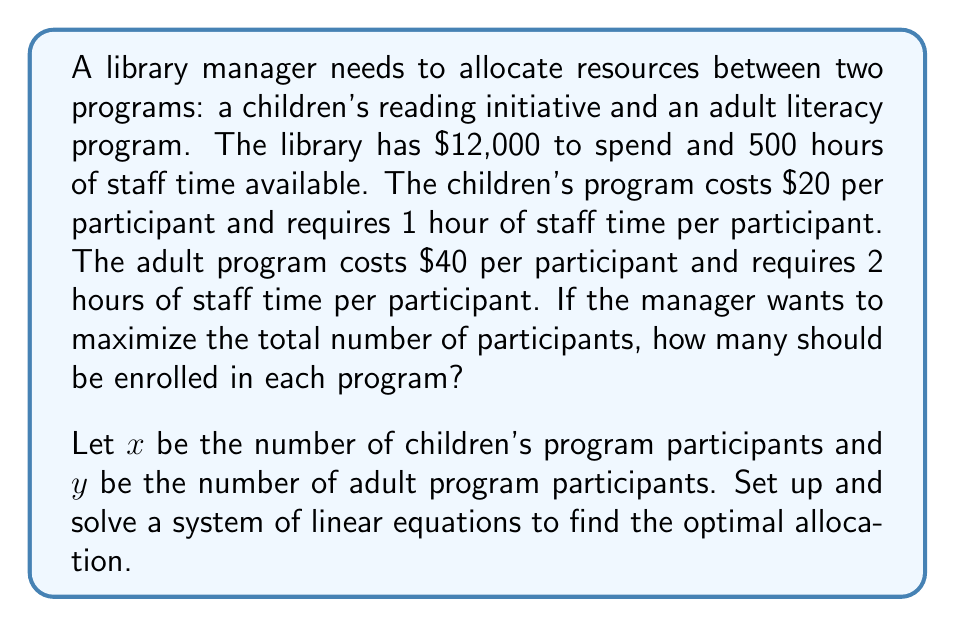Could you help me with this problem? 1. Set up the system of linear equations:

   Budget constraint: $20x + 40y = 12000$
   Time constraint: $x + 2y = 500$
   Objective: Maximize $x + y$

2. Simplify the budget constraint:
   $$20x + 40y = 12000$$
   $$x + 2y = 600$$

3. Now we have a system of two equations:
   $$x + 2y = 600$$
   $$x + 2y = 500$$

4. Solve for $x$ using substitution:
   From the second equation: $x = 500 - 2y$
   Substitute into the first equation:
   $$(500 - 2y) + 2y = 600$$
   $$500 = 600$$
   $$y = 50$$

5. Substitute $y = 50$ back into $x = 500 - 2y$:
   $$x = 500 - 2(50) = 400$$

6. Check the solution:
   Budget: $20(400) + 40(50) = 8000 + 2000 = 10000 \leq 12000$
   Time: $400 + 2(50) = 400 + 100 = 500$

The solution maximizes the total number of participants $(400 + 50 = 450)$ while satisfying both constraints.
Answer: 400 children's program participants, 50 adult program participants 